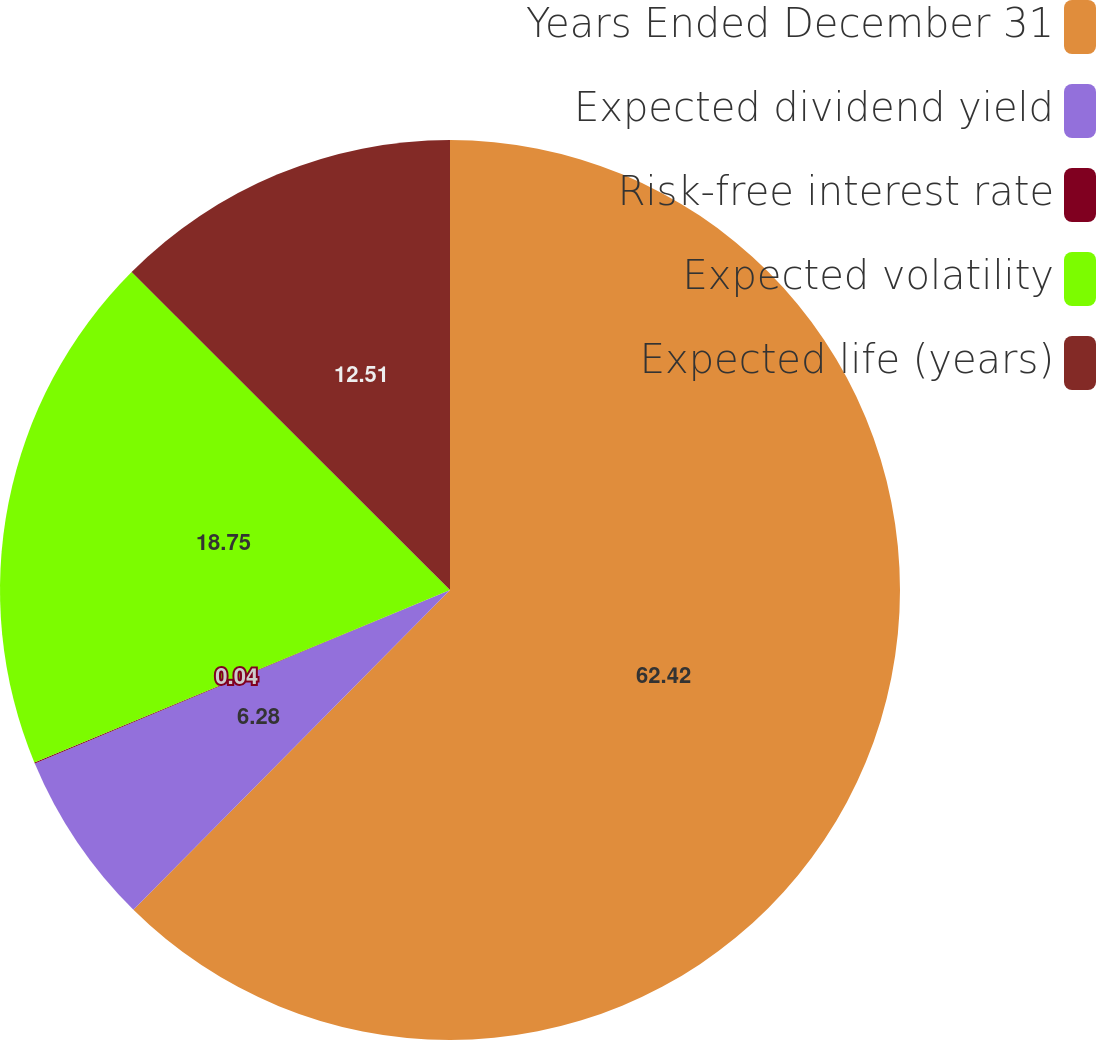<chart> <loc_0><loc_0><loc_500><loc_500><pie_chart><fcel>Years Ended December 31<fcel>Expected dividend yield<fcel>Risk-free interest rate<fcel>Expected volatility<fcel>Expected life (years)<nl><fcel>62.42%<fcel>6.28%<fcel>0.04%<fcel>18.75%<fcel>12.51%<nl></chart> 